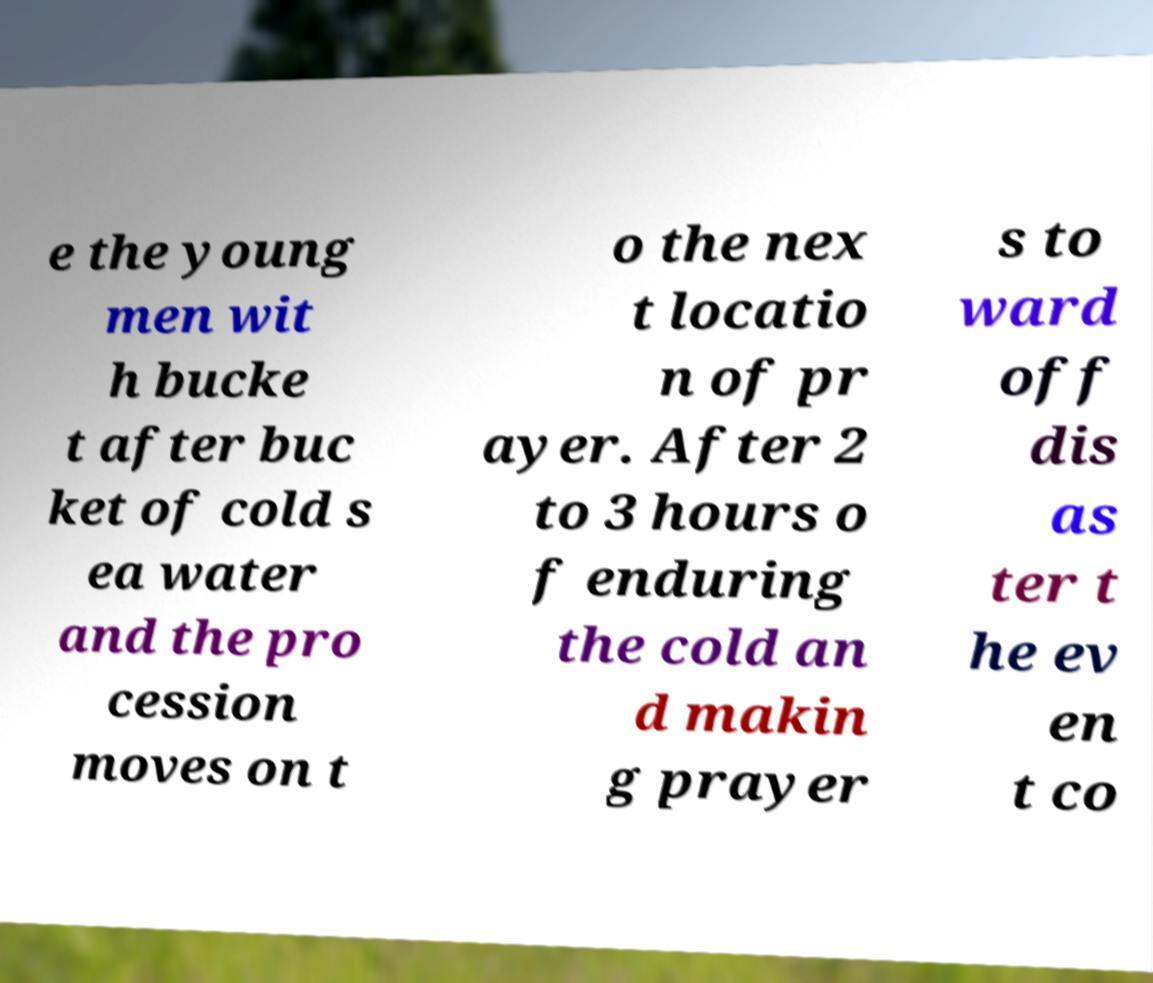There's text embedded in this image that I need extracted. Can you transcribe it verbatim? e the young men wit h bucke t after buc ket of cold s ea water and the pro cession moves on t o the nex t locatio n of pr ayer. After 2 to 3 hours o f enduring the cold an d makin g prayer s to ward off dis as ter t he ev en t co 